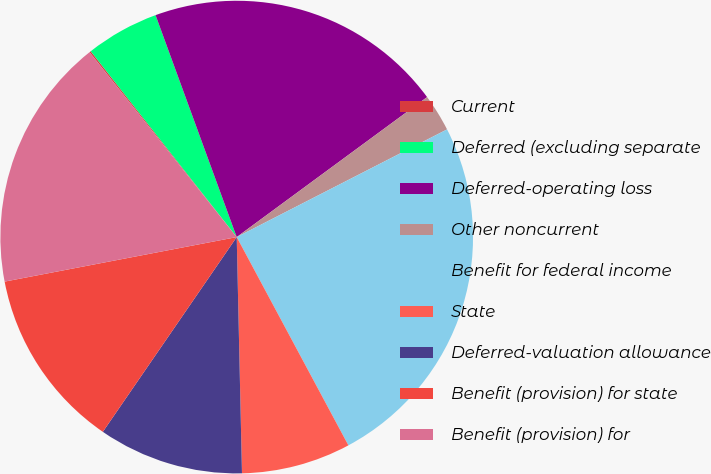<chart> <loc_0><loc_0><loc_500><loc_500><pie_chart><fcel>Current<fcel>Deferred (excluding separate<fcel>Deferred-operating loss<fcel>Other noncurrent<fcel>Benefit for federal income<fcel>State<fcel>Deferred-valuation allowance<fcel>Benefit (provision) for state<fcel>Benefit (provision) for<nl><fcel>0.1%<fcel>5.02%<fcel>20.49%<fcel>2.56%<fcel>24.7%<fcel>7.48%<fcel>9.94%<fcel>12.4%<fcel>17.32%<nl></chart> 